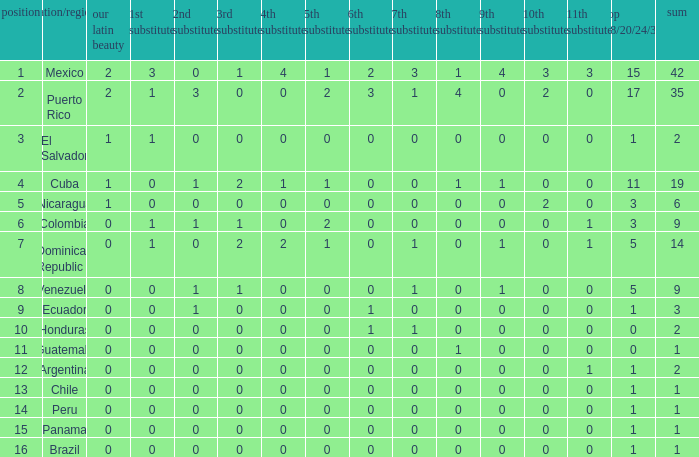Help me parse the entirety of this table. {'header': ['position', 'nation/region', 'our latin beauty', '1st substitute', '2nd substitute', '3rd substitute', '4th substitute', '5th substitute', '6th substitute', '7th substitute', '8th substitute', '9th substitute', '10th substitute', '11th substitute', 'top 18/20/24/30', 'sum'], 'rows': [['1', 'Mexico', '2', '3', '0', '1', '4', '1', '2', '3', '1', '4', '3', '3', '15', '42'], ['2', 'Puerto Rico', '2', '1', '3', '0', '0', '2', '3', '1', '4', '0', '2', '0', '17', '35'], ['3', 'El Salvador', '1', '1', '0', '0', '0', '0', '0', '0', '0', '0', '0', '0', '1', '2'], ['4', 'Cuba', '1', '0', '1', '2', '1', '1', '0', '0', '1', '1', '0', '0', '11', '19'], ['5', 'Nicaragua', '1', '0', '0', '0', '0', '0', '0', '0', '0', '0', '2', '0', '3', '6'], ['6', 'Colombia', '0', '1', '1', '1', '0', '2', '0', '0', '0', '0', '0', '1', '3', '9'], ['7', 'Dominican Republic', '0', '1', '0', '2', '2', '1', '0', '1', '0', '1', '0', '1', '5', '14'], ['8', 'Venezuela', '0', '0', '1', '1', '0', '0', '0', '1', '0', '1', '0', '0', '5', '9'], ['9', 'Ecuador', '0', '0', '1', '0', '0', '0', '1', '0', '0', '0', '0', '0', '1', '3'], ['10', 'Honduras', '0', '0', '0', '0', '0', '0', '1', '1', '0', '0', '0', '0', '0', '2'], ['11', 'Guatemala', '0', '0', '0', '0', '0', '0', '0', '0', '1', '0', '0', '0', '0', '1'], ['12', 'Argentina', '0', '0', '0', '0', '0', '0', '0', '0', '0', '0', '0', '1', '1', '2'], ['13', 'Chile', '0', '0', '0', '0', '0', '0', '0', '0', '0', '0', '0', '0', '1', '1'], ['14', 'Peru', '0', '0', '0', '0', '0', '0', '0', '0', '0', '0', '0', '0', '1', '1'], ['15', 'Panama', '0', '0', '0', '0', '0', '0', '0', '0', '0', '0', '0', '0', '1', '1'], ['16', 'Brazil', '0', '0', '0', '0', '0', '0', '0', '0', '0', '0', '0', '0', '1', '1']]} What is the 7th runner-up of the country with a 10th runner-up greater than 0, a 9th runner-up greater than 0, and an 8th runner-up greater than 1? None. 